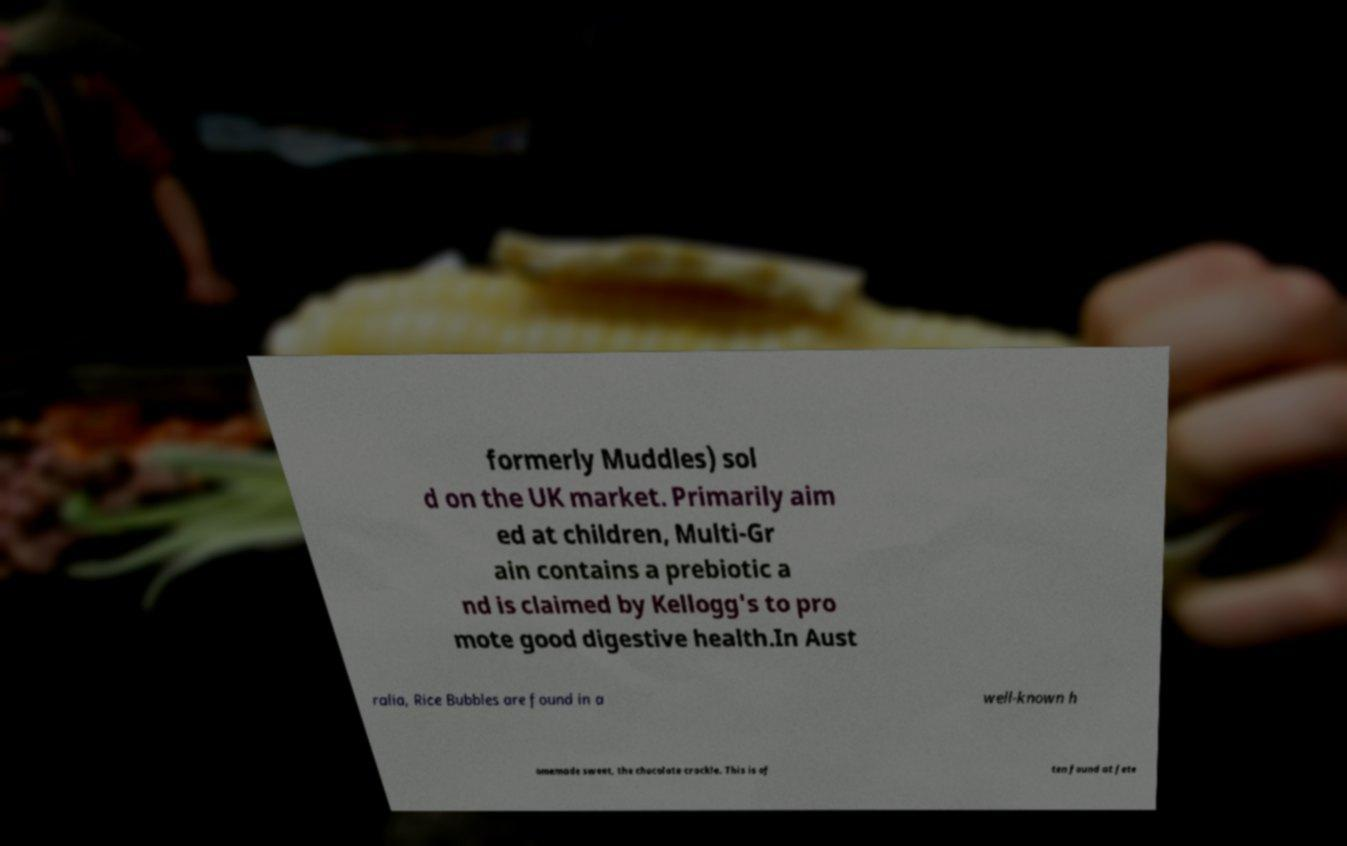Can you read and provide the text displayed in the image?This photo seems to have some interesting text. Can you extract and type it out for me? formerly Muddles) sol d on the UK market. Primarily aim ed at children, Multi-Gr ain contains a prebiotic a nd is claimed by Kellogg's to pro mote good digestive health.In Aust ralia, Rice Bubbles are found in a well-known h omemade sweet, the chocolate crackle. This is of ten found at fete 